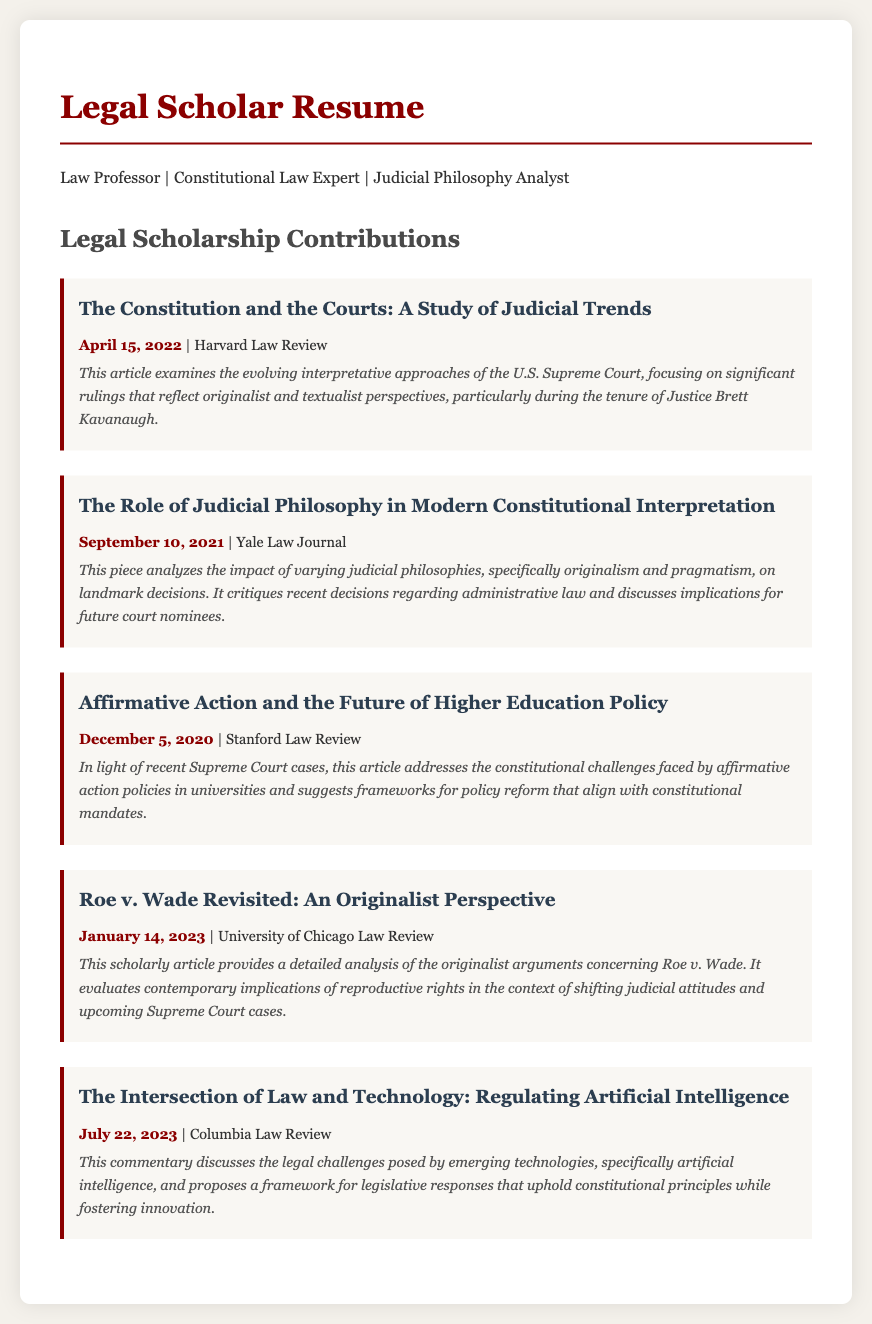What is the title of the first publication? The title of the first publication is the heading of the publication section in the document.
Answer: The Constitution and the Courts: A Study of Judicial Trends When was "The Role of Judicial Philosophy in Modern Constitutional Interpretation" published? The publication date is indicated under the title of this specific article.
Answer: September 10, 2021 Which journal published the article on affirmative action? The journal name is given directly after the publication date for that article.
Answer: Stanford Law Review How many publications are listed in the document? The total number of entries under the Legal Scholarship Contributions section indicates how many publications there are in the document.
Answer: Five What common theme is explored in the document's publications? All the publications focus on legal themes related to constitutional law and judicial philosophy, requiring synthesis of this conceptual understanding to identify a common theme.
Answer: Judicial Philosophy Which publication discusses Roe v. Wade? The title of the specific article is highlighted within the respective section of the document.
Answer: Roe v. Wade Revisited: An Originalist Perspective What is the focus of the commentary titled "The Intersection of Law and Technology"? The focus is derived from the abstract provided under this publication title in the document.
Answer: Regulating Artificial Intelligence What type of articles does this resume highlight? The document outlines the nature of work involved, with an emphasis on legal scholarship contributions.
Answer: Scholarly Articles 